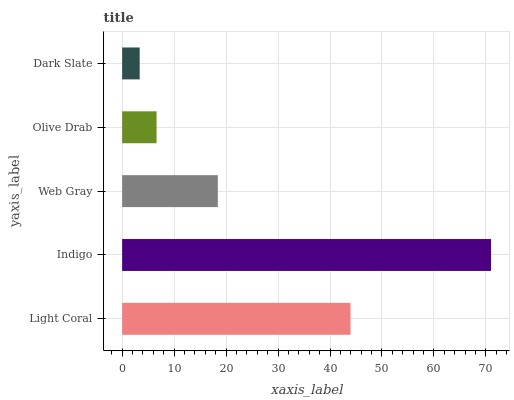Is Dark Slate the minimum?
Answer yes or no. Yes. Is Indigo the maximum?
Answer yes or no. Yes. Is Web Gray the minimum?
Answer yes or no. No. Is Web Gray the maximum?
Answer yes or no. No. Is Indigo greater than Web Gray?
Answer yes or no. Yes. Is Web Gray less than Indigo?
Answer yes or no. Yes. Is Web Gray greater than Indigo?
Answer yes or no. No. Is Indigo less than Web Gray?
Answer yes or no. No. Is Web Gray the high median?
Answer yes or no. Yes. Is Web Gray the low median?
Answer yes or no. Yes. Is Dark Slate the high median?
Answer yes or no. No. Is Indigo the low median?
Answer yes or no. No. 